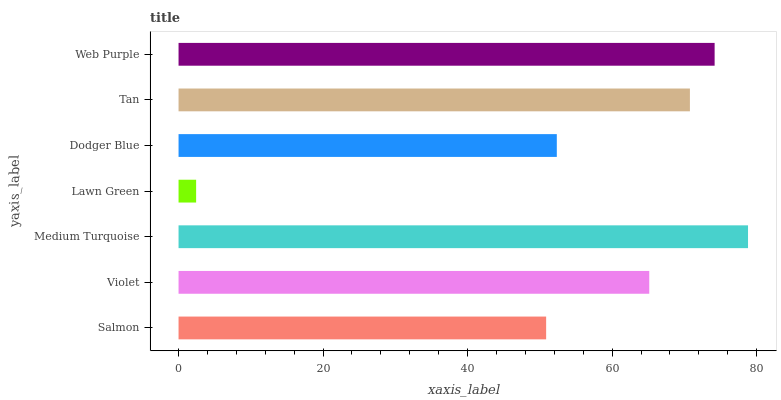Is Lawn Green the minimum?
Answer yes or no. Yes. Is Medium Turquoise the maximum?
Answer yes or no. Yes. Is Violet the minimum?
Answer yes or no. No. Is Violet the maximum?
Answer yes or no. No. Is Violet greater than Salmon?
Answer yes or no. Yes. Is Salmon less than Violet?
Answer yes or no. Yes. Is Salmon greater than Violet?
Answer yes or no. No. Is Violet less than Salmon?
Answer yes or no. No. Is Violet the high median?
Answer yes or no. Yes. Is Violet the low median?
Answer yes or no. Yes. Is Medium Turquoise the high median?
Answer yes or no. No. Is Web Purple the low median?
Answer yes or no. No. 